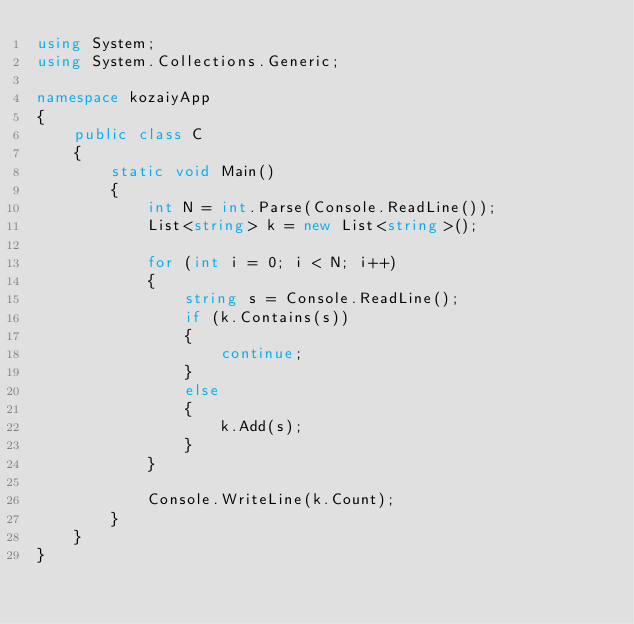Convert code to text. <code><loc_0><loc_0><loc_500><loc_500><_C#_>using System;
using System.Collections.Generic;

namespace kozaiyApp
{
    public class C
    {
        static void Main()
        {
            int N = int.Parse(Console.ReadLine());
            List<string> k = new List<string>();

            for (int i = 0; i < N; i++)
            {
                string s = Console.ReadLine();
                if (k.Contains(s))
                {
                    continue;
                }
                else
                {
                    k.Add(s);
                }
            }

            Console.WriteLine(k.Count);
        }
    }
}
</code> 